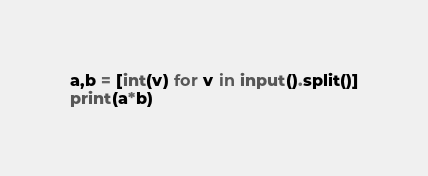<code> <loc_0><loc_0><loc_500><loc_500><_Python_>a,b = [int(v) for v in input().split()]
print(a*b)
</code> 